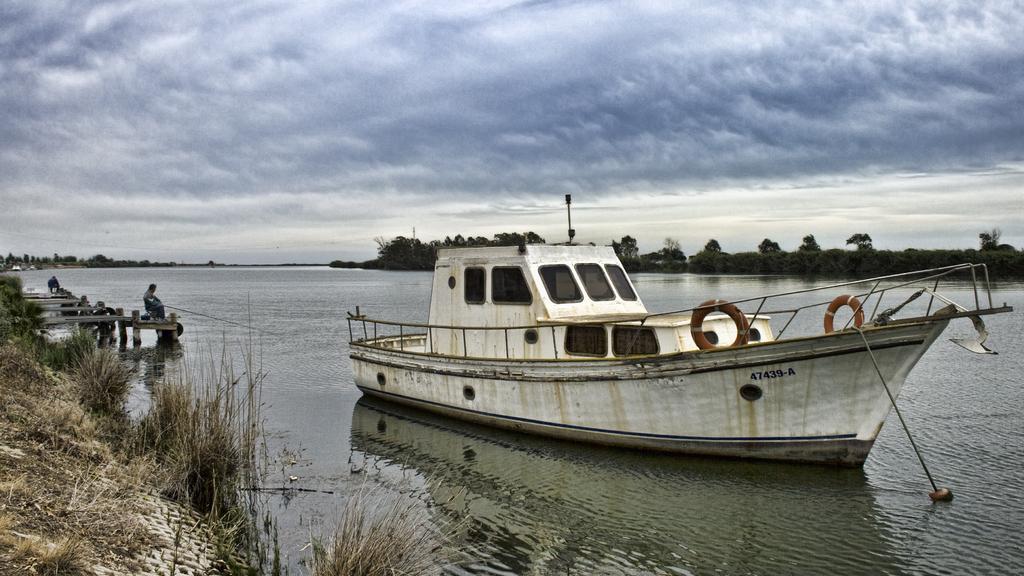Please provide a concise description of this image. In the center of the image we can see a boat. In the background of the image we can see the trees, water. On the left side of the image we can see the plants, bridge and two people are sitting and a man is holding a stick. At the top of the image we can see the clouds in the sky. 